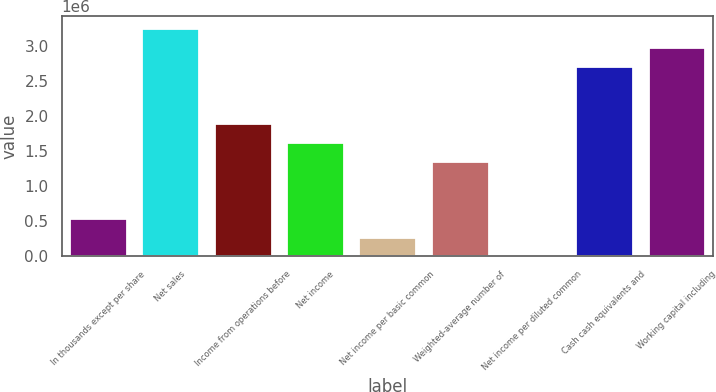Convert chart to OTSL. <chart><loc_0><loc_0><loc_500><loc_500><bar_chart><fcel>In thousands except per share<fcel>Net sales<fcel>Income from operations before<fcel>Net income<fcel>Net income per basic common<fcel>Weighted-average number of<fcel>Net income per diluted common<fcel>Cash cash equivalents and<fcel>Working capital including<nl><fcel>544651<fcel>3.26788e+06<fcel>1.90627e+06<fcel>1.63394e+06<fcel>272328<fcel>1.36162e+06<fcel>4.69<fcel>2.72323e+06<fcel>2.99556e+06<nl></chart> 